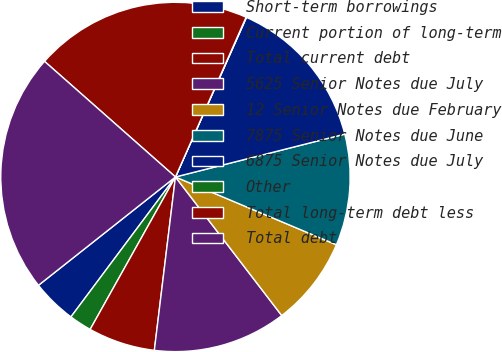Convert chart. <chart><loc_0><loc_0><loc_500><loc_500><pie_chart><fcel>Short-term borrowings<fcel>Current portion of long-term<fcel>Total current debt<fcel>5625 Senior Notes due July<fcel>12 Senior Notes due February<fcel>7875 Senior Notes due June<fcel>6875 Senior Notes due July<fcel>Other<fcel>Total long-term debt less<fcel>Total debt<nl><fcel>4.14%<fcel>2.09%<fcel>6.19%<fcel>12.34%<fcel>8.24%<fcel>10.29%<fcel>14.39%<fcel>0.04%<fcel>20.11%<fcel>22.16%<nl></chart> 